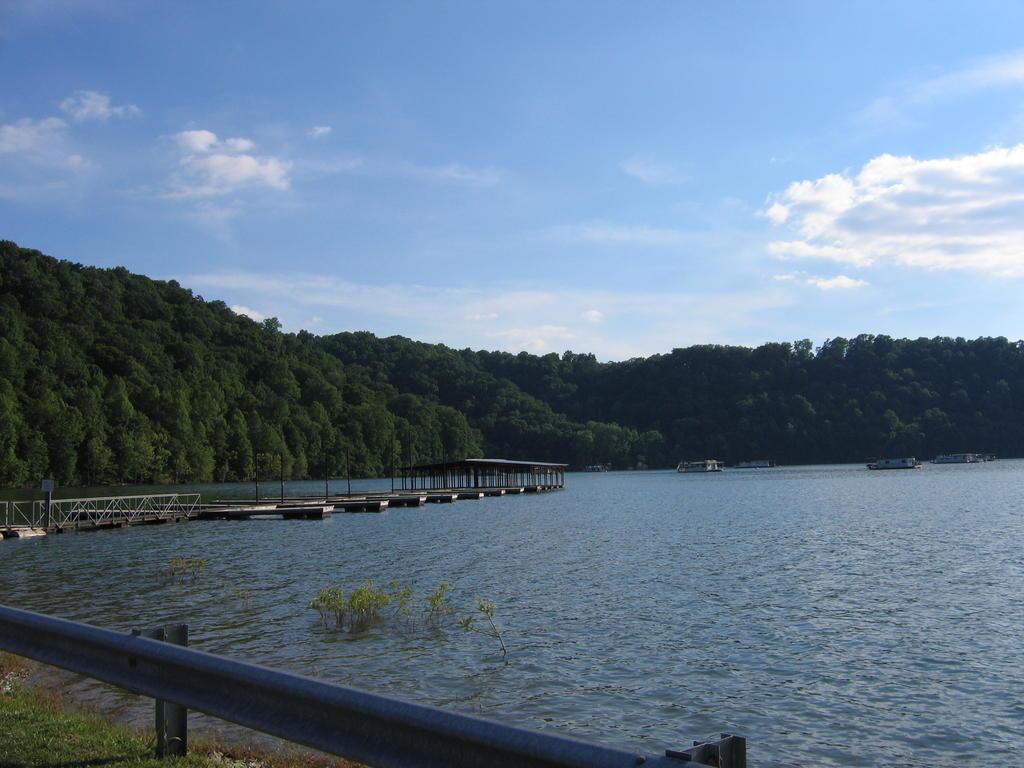Can you describe this image briefly? In this image, we can see ships sailing in the water. We can also see a bridge across the water. There are trees which are green in color. We can also see the sky with clouds. 